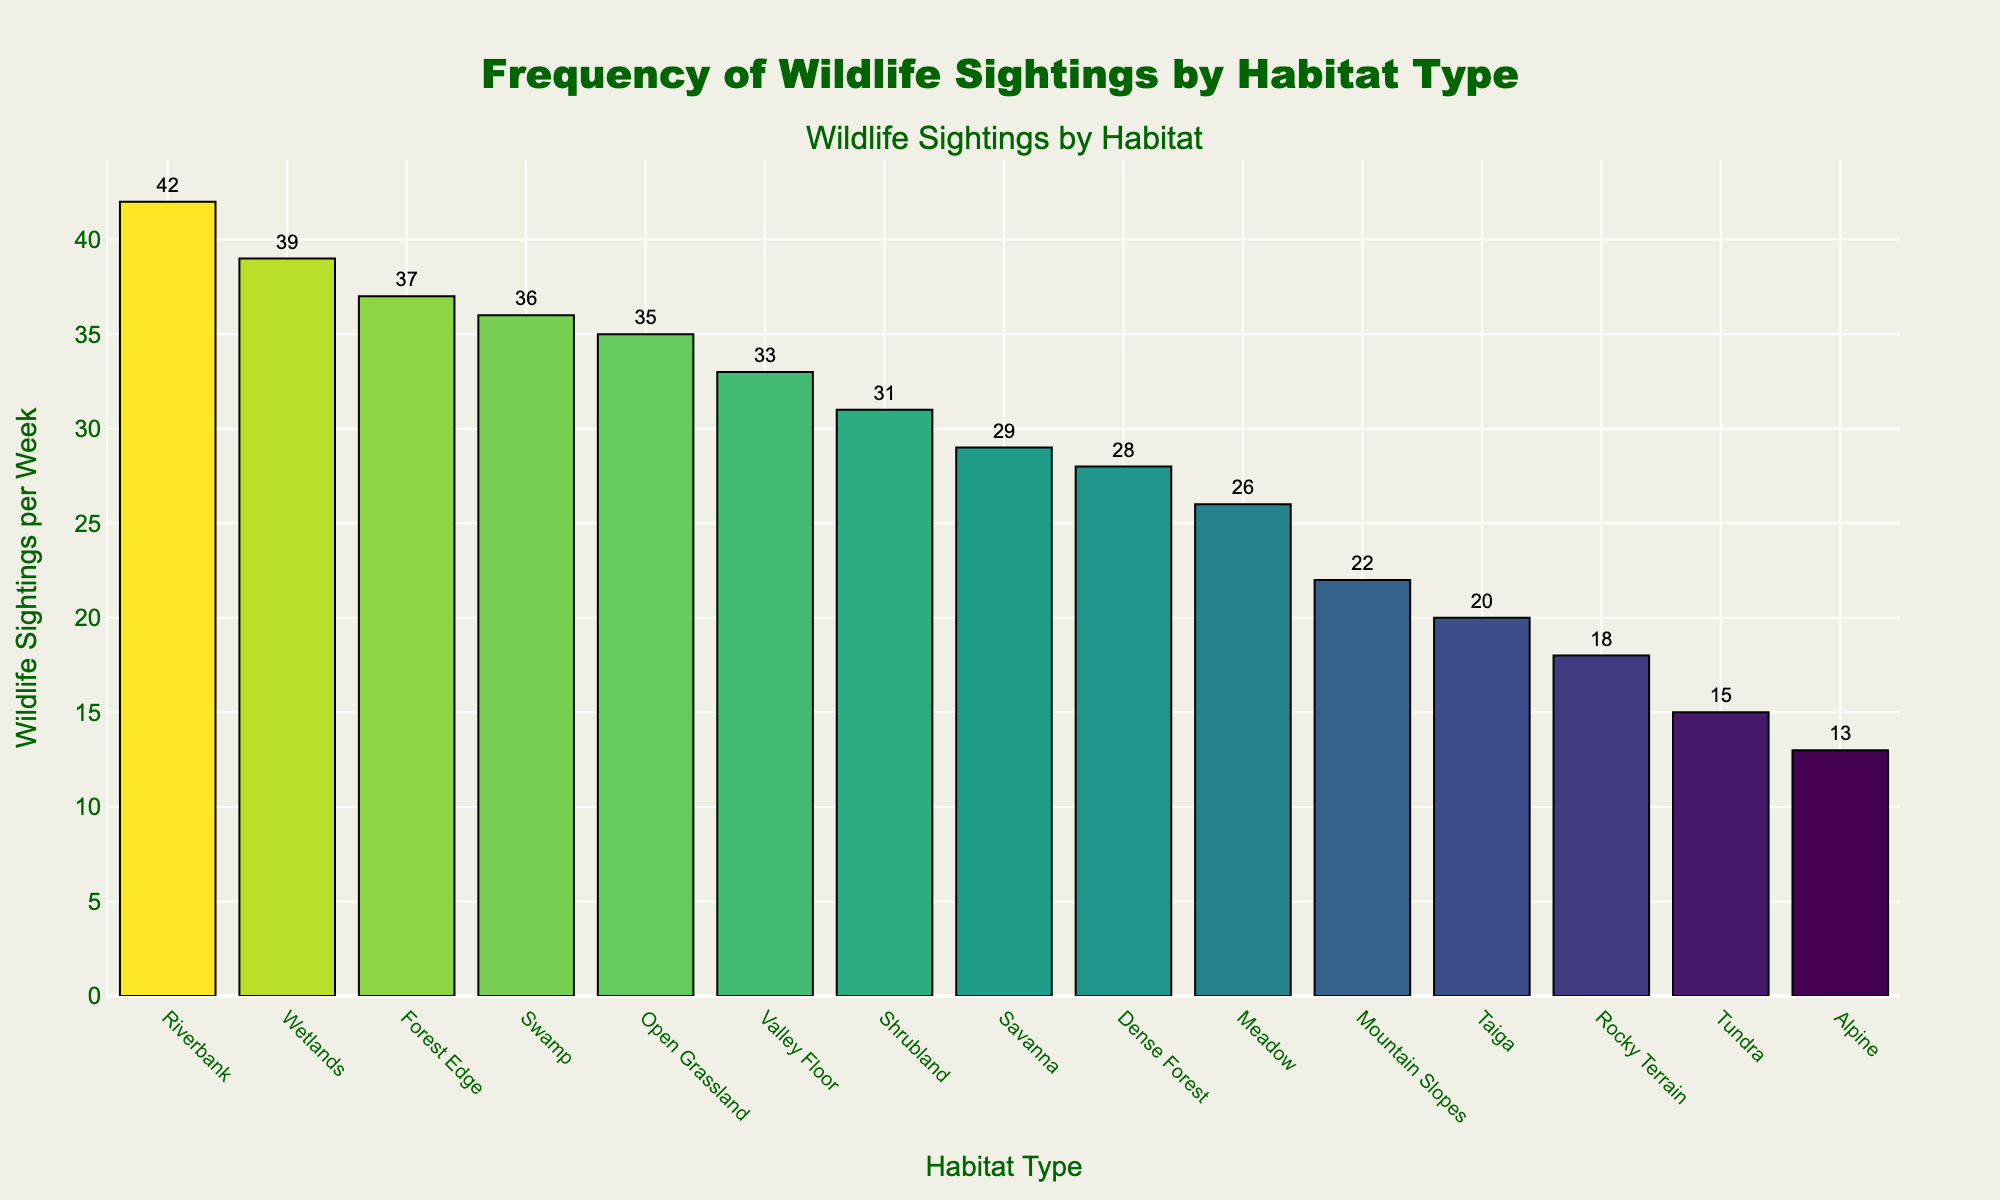Which habitat has the highest frequency of wildlife sightings? The tallest bar in the chart represents the habitat with the highest number of wildlife sightings. According to the chart, the tallest bar corresponds to the Riverbank habitat.
Answer: Riverbank Which habitat has the lowest frequency of wildlife sightings? The shortest bar in the chart represents the habitat with the lowest number of wildlife sightings. According to the chart, the shortest bar corresponds to the Alpine habitat.
Answer: Alpine Which habitats have more than 35 wildlife sightings per week? Look for bars that extend beyond the 35-mark on the y-axis. The habitats fitting this criterion are Riverbank (42), Wetlands (39), Forest Edge (37), and Swamp (36).
Answer: Riverbank, Wetlands, Forest Edge, Swamp What is the total number of wildlife sightings per week for Mountain Slopes and Rocky Terrain combined? Locate the bars for Mountain Slopes and Rocky Terrain and add their values. Mountain Slopes have 22 sightings and Rocky Terrain has 18 sightings. 22 + 18 = 40.
Answer: 40 What is the average number of wildlife sightings per week across all habitats? Add the number of wildlife sightings for all habitats and divide by the number of habitats. (28+35+42+39+18+31+22+33+37+29+26+36+15+20+13) / 15 = 424 / 15 ≈ 28.27
Answer: ≈ 28.27 Is the number of wildlife sightings in the Shrubland habitat greater than in the Meadow habitat? Compare the heights of the bars for Shrubland and Meadow. Shrubland has 31 sightings, and Meadow has 26 sightings. Since 31 > 26, Shrubland has more sightings.
Answer: Yes What is the median number of weekly wildlife sightings in all habitats? List the number of sightings in ascending order and find the middle value. Ordered values: 13, 15, 18, 20, 22, 26, 28, 29, 31, 33, 35, 36, 37, 39, 42. The middle value (8th in ascending order) is 29.
Answer: 29 By how much do the wildlife sightings per week in the Valley Floor exceed those in the Tundra? The Valley Floor has 33 sightings and the Tundra has 15 sightings. The difference is 33 - 15 = 18.
Answer: 18 Which habitat has a frequency of wildlife sightings closest to 30 per week? Identify bars closest to the 30-mark on the y-axis. The closest values are Shrubland (31) and Savanna (29).
Answer: Shrubland or Savanna How many habitats have fewer than 20 wildlife sightings per week? Count the bars that fall below the 20-mark on the y-axis: Rocky Terrain (18), Tundra (15), and Alpine (13). So, there are 3 such habitats.
Answer: 3 